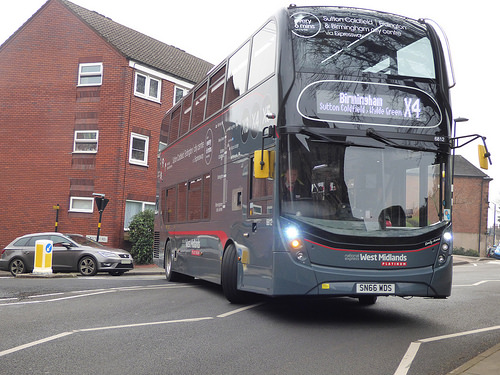<image>
Is the bus to the left of the building? No. The bus is not to the left of the building. From this viewpoint, they have a different horizontal relationship. Where is the bus in relation to the building? Is it behind the building? No. The bus is not behind the building. From this viewpoint, the bus appears to be positioned elsewhere in the scene. 